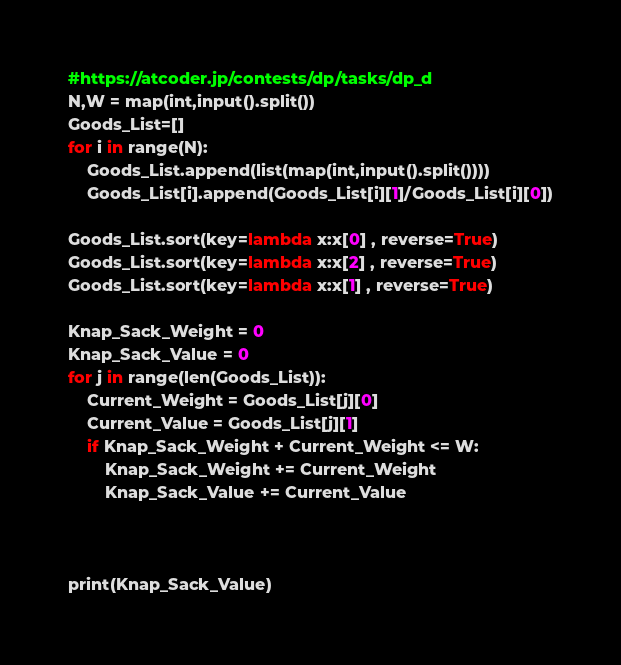<code> <loc_0><loc_0><loc_500><loc_500><_Python_>#https://atcoder.jp/contests/dp/tasks/dp_d
N,W = map(int,input().split())
Goods_List=[]
for i in range(N):
    Goods_List.append(list(map(int,input().split())))
    Goods_List[i].append(Goods_List[i][1]/Goods_List[i][0])

Goods_List.sort(key=lambda x:x[0] , reverse=True)
Goods_List.sort(key=lambda x:x[2] , reverse=True)
Goods_List.sort(key=lambda x:x[1] , reverse=True)

Knap_Sack_Weight = 0
Knap_Sack_Value = 0
for j in range(len(Goods_List)):
    Current_Weight = Goods_List[j][0]
    Current_Value = Goods_List[j][1]
    if Knap_Sack_Weight + Current_Weight <= W:
        Knap_Sack_Weight += Current_Weight
        Knap_Sack_Value += Current_Value
        
        
        
print(Knap_Sack_Value)</code> 